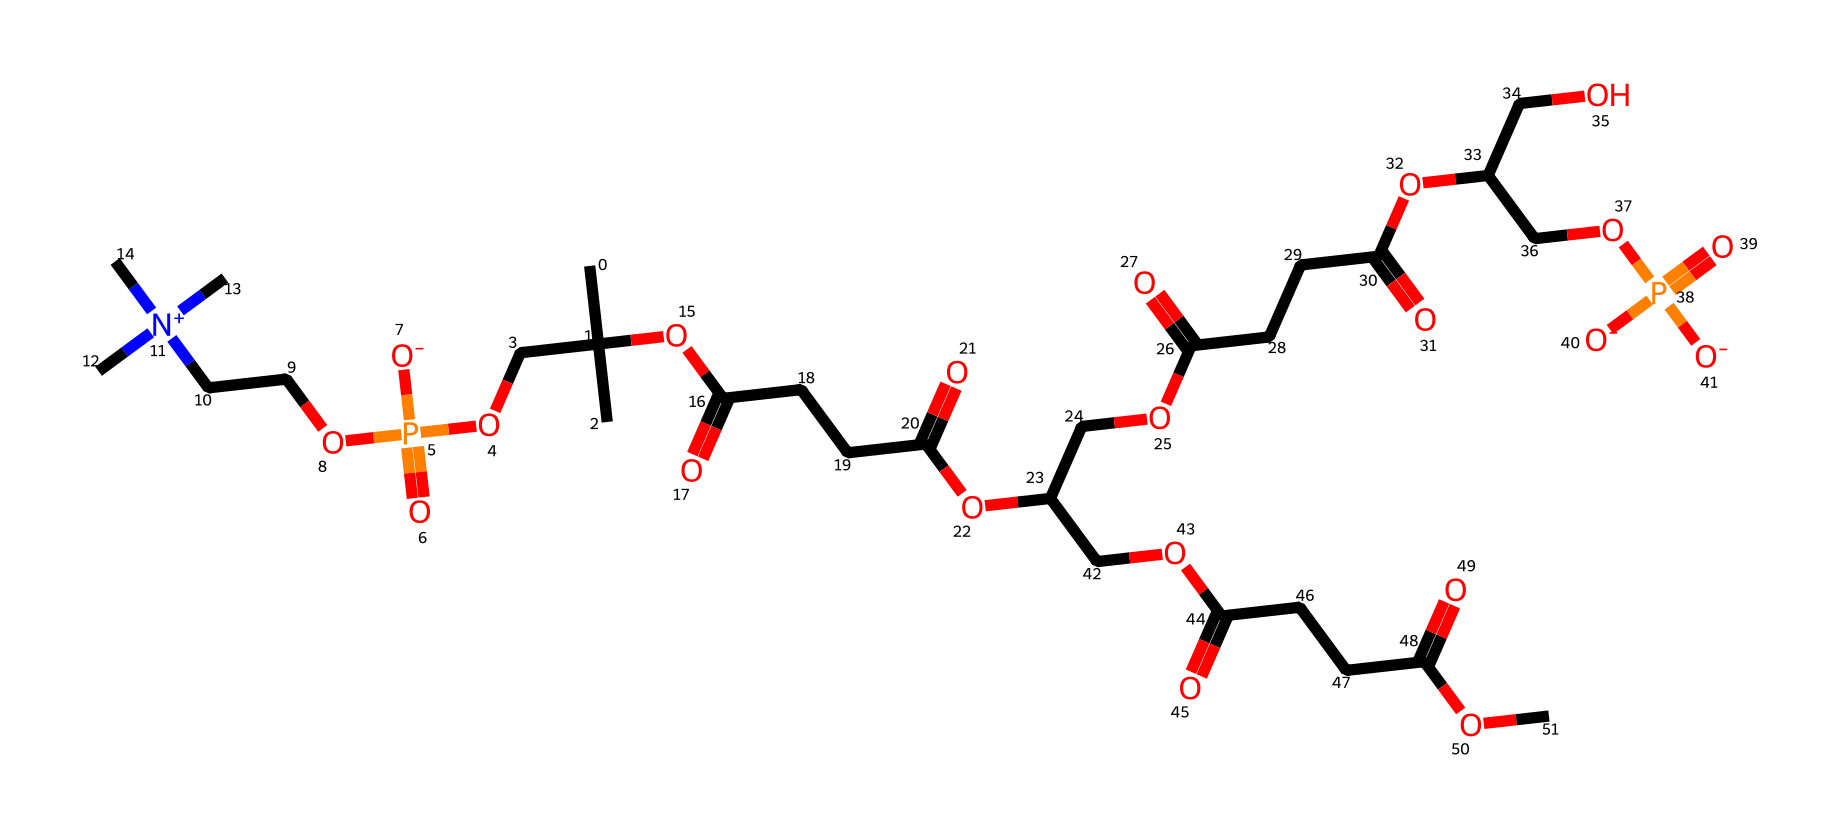What is the main functional group present in lecithin? Lecithin contains a phosphate group, which is a defining characteristic of phospholipids, lending it emulsifying properties.
Answer: phosphate group How many carbon atoms are in the molecular structure of lecithin? By analyzing the SMILES representation, the structure reveals multiple aliphatic chains containing a total of approximately 18 carbon atoms.
Answer: 18 What type of chemical is lecithin classified as? Lecithin is classified as a phospholipid due to the presence of a phosphate group and fatty acid chains.
Answer: phospholipid How many ester bonds are present in the structure of lecithin? The ester bonds can be counted by identifying the carbonyl groups leading into the ether linkages, typically resulting in about three ester bonds.
Answer: 3 What role does lecithin play in pet food? Lecithin acts as an emulsifier, which helps to mix water and fats in the formulation of pet food, ensuring a uniform texture.
Answer: emulsifier Which part of the lecithin structure contributes to its hydrophilic nature? The phosphate group is hydrophilic, allowing lecithin to interact well with water and contribute to its emulsifying properties.
Answer: phosphate group 